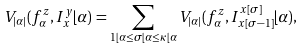Convert formula to latex. <formula><loc_0><loc_0><loc_500><loc_500>V _ { | \alpha | } ( f _ { \alpha } ^ { z } , I _ { x } ^ { y } \lfloor \alpha ) = \sum _ { 1 \lfloor \alpha \leq \sigma \lfloor \alpha \leq \kappa \lfloor \alpha } V _ { | \alpha | } ( f _ { \alpha } ^ { z } , I _ { x [ \sigma - 1 ] } ^ { x [ \sigma ] } \lfloor \alpha ) ,</formula> 